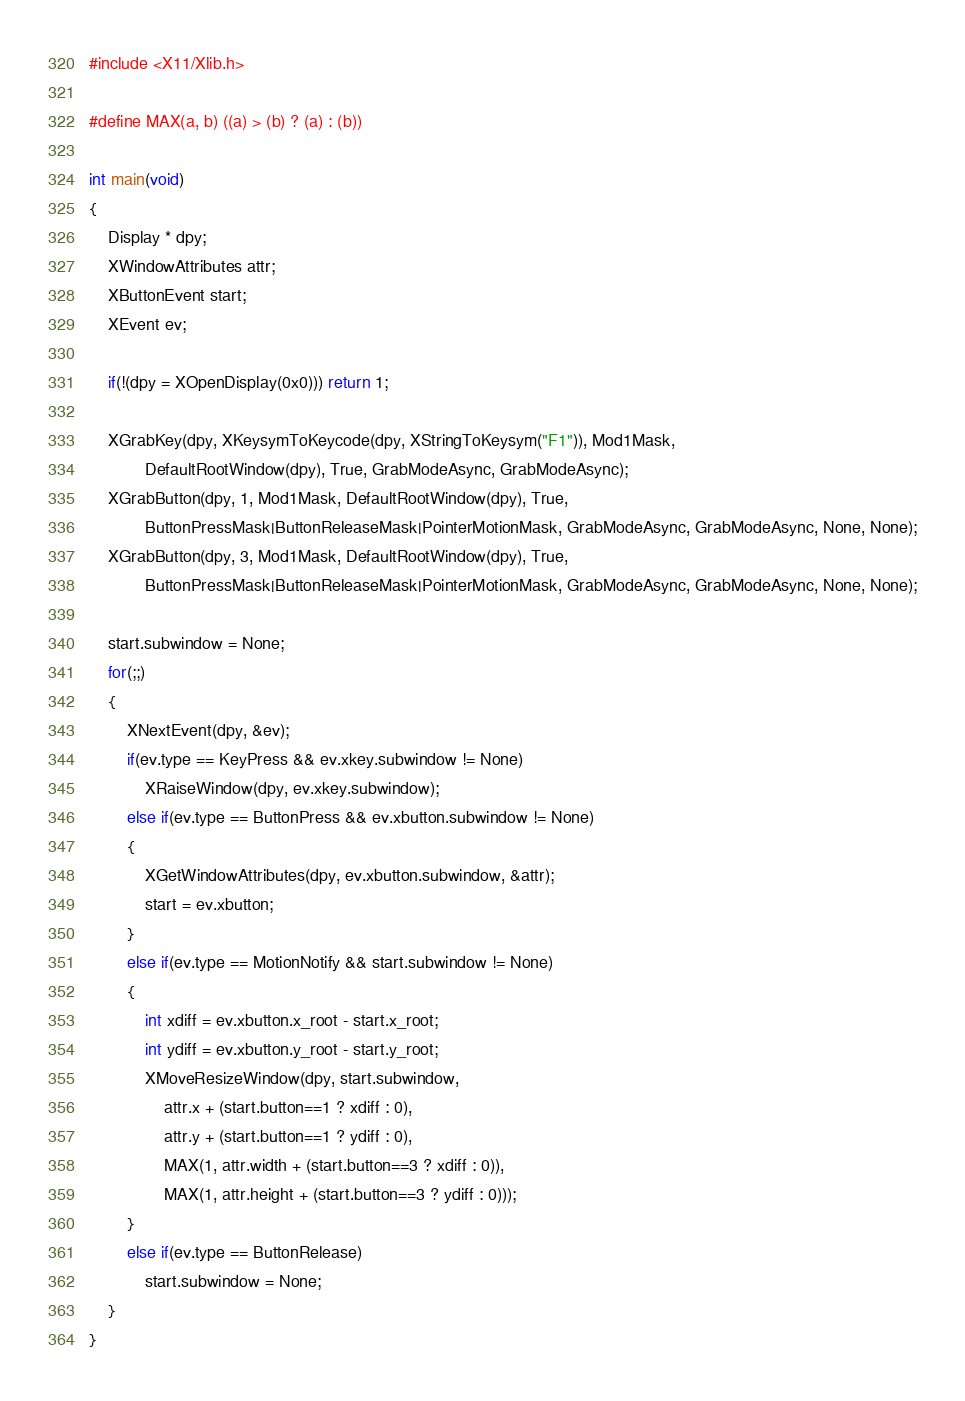<code> <loc_0><loc_0><loc_500><loc_500><_C_>#include <X11/Xlib.h>

#define MAX(a, b) ((a) > (b) ? (a) : (b))

int main(void)
{
    Display * dpy;
    XWindowAttributes attr;
    XButtonEvent start;
    XEvent ev;

    if(!(dpy = XOpenDisplay(0x0))) return 1;

    XGrabKey(dpy, XKeysymToKeycode(dpy, XStringToKeysym("F1")), Mod1Mask,
            DefaultRootWindow(dpy), True, GrabModeAsync, GrabModeAsync);
    XGrabButton(dpy, 1, Mod1Mask, DefaultRootWindow(dpy), True,
            ButtonPressMask|ButtonReleaseMask|PointerMotionMask, GrabModeAsync, GrabModeAsync, None, None);
    XGrabButton(dpy, 3, Mod1Mask, DefaultRootWindow(dpy), True,
            ButtonPressMask|ButtonReleaseMask|PointerMotionMask, GrabModeAsync, GrabModeAsync, None, None);

    start.subwindow = None;
    for(;;)
    {
        XNextEvent(dpy, &ev);
        if(ev.type == KeyPress && ev.xkey.subwindow != None)
            XRaiseWindow(dpy, ev.xkey.subwindow);
        else if(ev.type == ButtonPress && ev.xbutton.subwindow != None)
        {
            XGetWindowAttributes(dpy, ev.xbutton.subwindow, &attr);
            start = ev.xbutton;
        }
        else if(ev.type == MotionNotify && start.subwindow != None)
        {
            int xdiff = ev.xbutton.x_root - start.x_root;
            int ydiff = ev.xbutton.y_root - start.y_root;
            XMoveResizeWindow(dpy, start.subwindow,
                attr.x + (start.button==1 ? xdiff : 0),
                attr.y + (start.button==1 ? ydiff : 0),
                MAX(1, attr.width + (start.button==3 ? xdiff : 0)),
                MAX(1, attr.height + (start.button==3 ? ydiff : 0)));
        }
        else if(ev.type == ButtonRelease)
            start.subwindow = None;
    }
}
</code> 